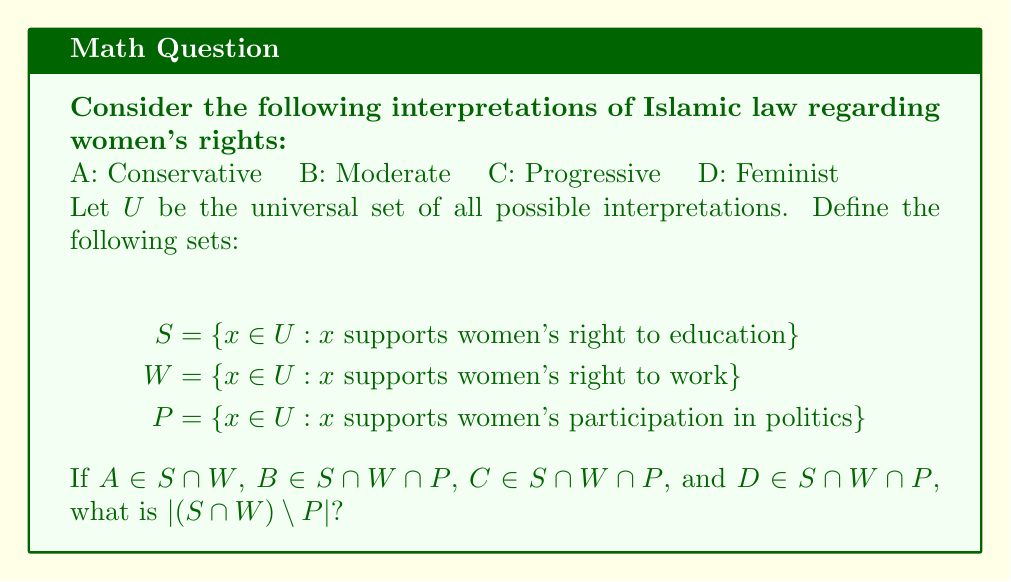Teach me how to tackle this problem. To solve this problem, we need to analyze the given information using set theory:

1. We have four interpretations: A, B, C, and D.

2. The sets are defined as follows:
   $S$: interpretations supporting women's right to education
   $W$: interpretations supporting women's right to work
   $P$: interpretations supporting women's participation in politics

3. We're given the following information:
   A $\in S \cap W$
   B $\in S \cap W \cap P$
   C $\in S \cap W \cap P$
   D $\in S \cap W \cap P$

4. The question asks for $|(S \cap W) \setminus P|$, which means the number of elements in the set that are in both $S$ and $W$ but not in $P$.

5. We can see that:
   - A is in $S \cap W$ but not explicitly stated to be in $P$
   - B, C, and D are all in $S \cap W \cap P$

6. Therefore, A is the only element that we know for certain is in $(S \cap W) \setminus P$.

7. We cannot assume anything about other possible interpretations, as the problem doesn't provide information about the complete universal set $U$.

Thus, based on the given information, we can conclude that there is at least one element in $(S \cap W) \setminus P$, which is A.
Answer: $|(S \cap W) \setminus P| = 1$ 